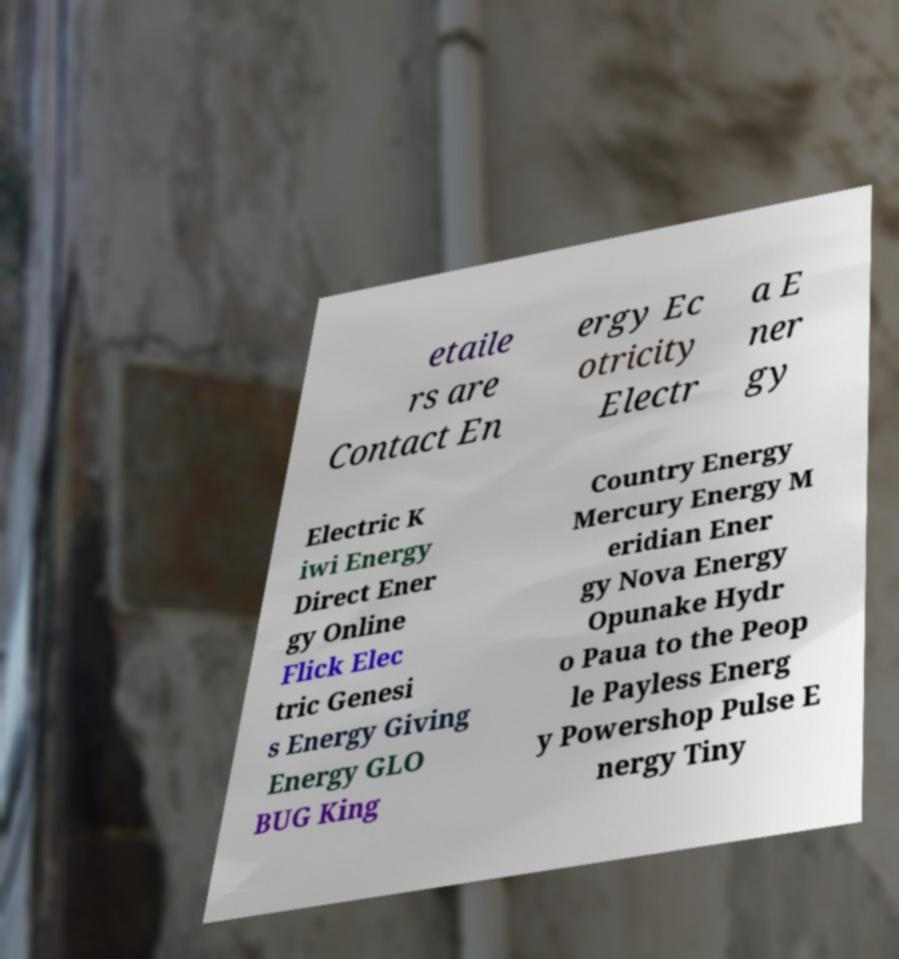There's text embedded in this image that I need extracted. Can you transcribe it verbatim? etaile rs are Contact En ergy Ec otricity Electr a E ner gy Electric K iwi Energy Direct Ener gy Online Flick Elec tric Genesi s Energy Giving Energy GLO BUG King Country Energy Mercury Energy M eridian Ener gy Nova Energy Opunake Hydr o Paua to the Peop le Payless Energ y Powershop Pulse E nergy Tiny 